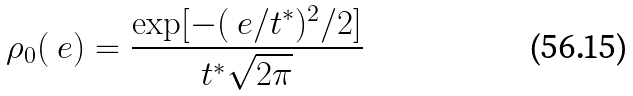<formula> <loc_0><loc_0><loc_500><loc_500>\rho _ { 0 } ( \ e ) = \frac { \exp [ - ( \ e / t ^ { * } ) ^ { 2 } / 2 ] } { t ^ { * } \sqrt { 2 \pi } }</formula> 